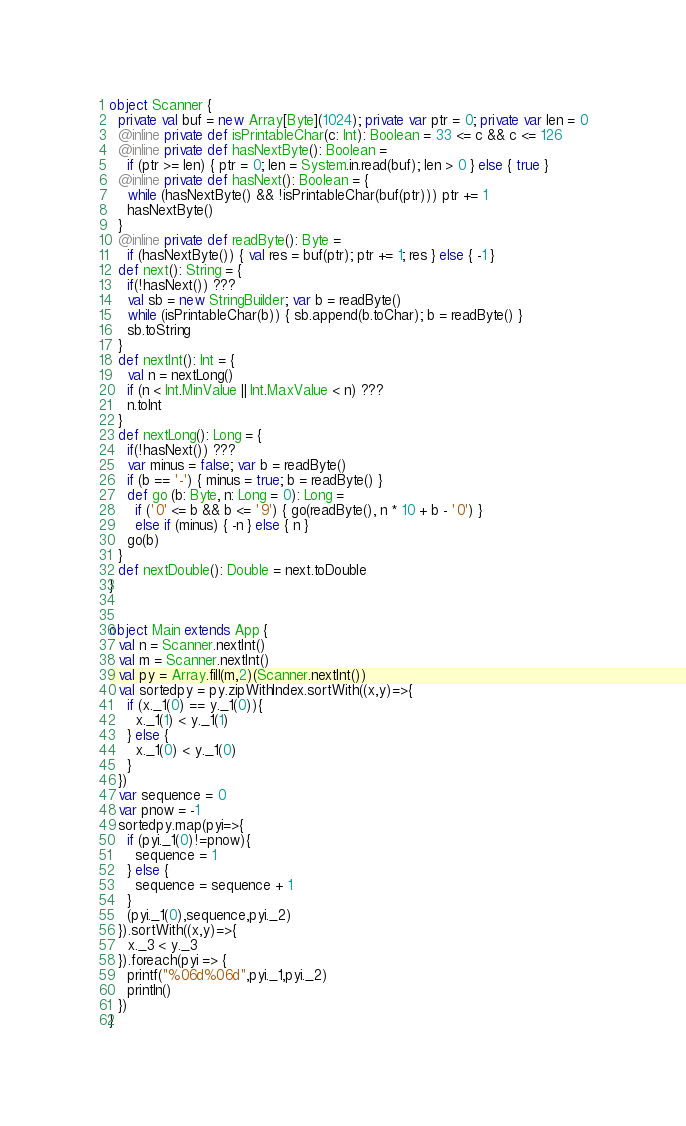Convert code to text. <code><loc_0><loc_0><loc_500><loc_500><_Scala_>object Scanner {
  private val buf = new Array[Byte](1024); private var ptr = 0; private var len = 0
  @inline private def isPrintableChar(c: Int): Boolean = 33 <= c && c <= 126
  @inline private def hasNextByte(): Boolean =
    if (ptr >= len) { ptr = 0; len = System.in.read(buf); len > 0 } else { true }
  @inline private def hasNext(): Boolean = {
    while (hasNextByte() && !isPrintableChar(buf(ptr))) ptr += 1
    hasNextByte()
  }
  @inline private def readByte(): Byte =
    if (hasNextByte()) { val res = buf(ptr); ptr += 1; res } else { -1 }
  def next(): String = {
    if(!hasNext()) ???
    val sb = new StringBuilder; var b = readByte()
    while (isPrintableChar(b)) { sb.append(b.toChar); b = readByte() }
    sb.toString
  }
  def nextInt(): Int = {
    val n = nextLong()
    if (n < Int.MinValue || Int.MaxValue < n) ???
    n.toInt
  }
  def nextLong(): Long = {
    if(!hasNext()) ???
    var minus = false; var b = readByte()
    if (b == '-') { minus = true; b = readByte() }
    def go (b: Byte, n: Long = 0): Long =
      if ('0' <= b && b <= '9') { go(readByte(), n * 10 + b - '0') }
      else if (minus) { -n } else { n }
    go(b)
  }
  def nextDouble(): Double = next.toDouble
}


object Main extends App {
  val n = Scanner.nextInt()
  val m = Scanner.nextInt()
  val py = Array.fill(m,2)(Scanner.nextInt())
  val sortedpy = py.zipWithIndex.sortWith((x,y)=>{
    if (x._1(0) == y._1(0)){
      x._1(1) < y._1(1)
    } else {
      x._1(0) < y._1(0)
    }
  })
  var sequence = 0
  var pnow = -1
  sortedpy.map(pyi=>{
    if (pyi._1(0)!=pnow){
      sequence = 1
    } else {
      sequence = sequence + 1
    }
    (pyi._1(0),sequence,pyi._2)
  }).sortWith((x,y)=>{
    x._3 < y._3
  }).foreach(pyi => {
    printf("%06d%06d",pyi._1,pyi._2)
    println()
  })
}</code> 